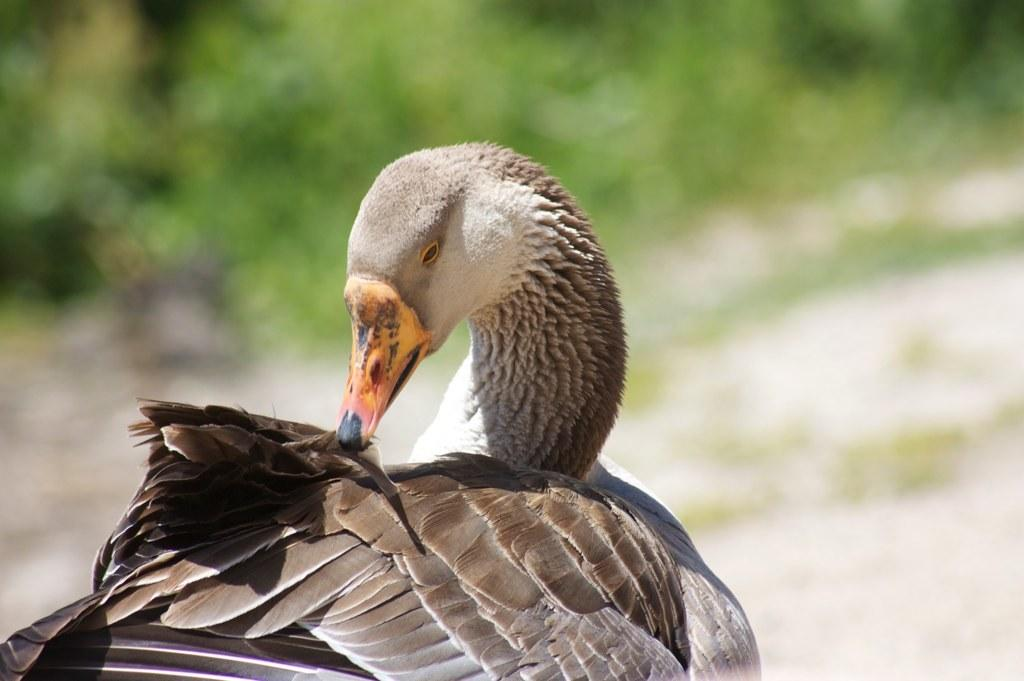What type of animal is present in the image? There is a bird in the image. Can you describe the background of the image? The background of the image is blurred. What type of thing is cats eating in the image? There are no cats or oatmeal present in the image, so it cannot be determined what, if anything, they might be eating. 